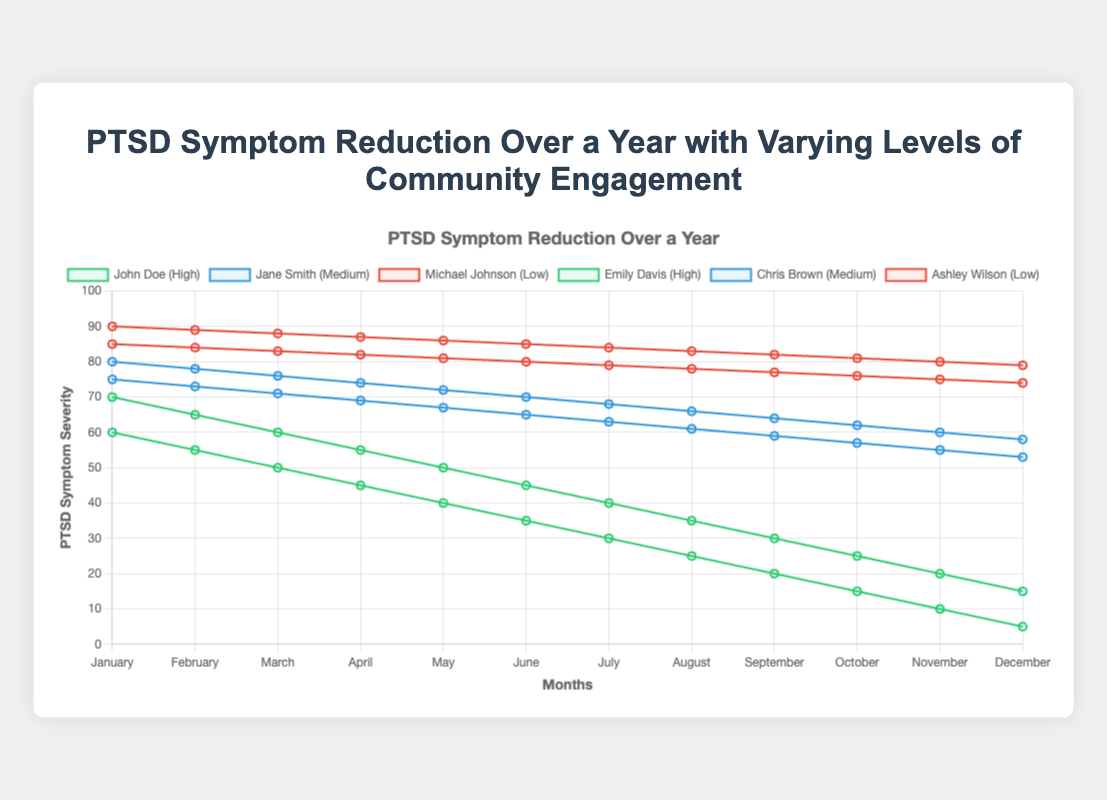What's the difference in PTSD symptoms between John Doe and Michael Johnson in January? John Doe's PTSD symptoms in January are 70, while Michael Johnson's are 90. The difference is 90 - 70 = 20.
Answer: 20 Comparing Emily Davis and Ashley Wilson's PTSD symptoms, who shows a greater reduction by December? Emily Davis starts with 60 symptoms and reduces to 5 by December, a reduction of 60 - 5 = 55. Ashley Wilson starts at 85 and reduces to 74, a reduction of 85 - 74 = 11. Emily Davis shows a greater reduction.
Answer: Emily Davis What is the average PTSD symptom severity for participants with high community engagement in July? John Doe has 40 symptoms, and Emily Davis has 30 symptoms in July. The average is (40 + 30) / 2 = 35.
Answer: 35 Which month sees the largest reduction in symptoms for Jane Smith? Jane Smith's symptoms drop from 80 to 78 in February (2 less), 78 to 76 in March (2 less), and so on. The largest monthly drop is consistently 2.
Answer: 2 (consistent each month) How do the PTSD symptoms in February compare between John Doe and Chris Brown? In February, John Doe has 65 PTSD symptoms, and Chris Brown has 73. Since 65 < 73, John Doe has fewer symptoms.
Answer: John Doe has fewer symptoms What is the median PTSD symptom severity for Michael Johnson over the year? Michael Johnson's symptoms are [90, 89, 88, 87, 86, 85, 84, 83, 82, 81, 80, 79]. The median is the average of the 6th (85) and 7th (84) values: (85 + 84) / 2 = 84.5.
Answer: 84.5 How does Ashley Wilson's PTSD symptom trend compare to the general trend for participants with low community engagement? Both Ashley Wilson and Michael Johnson show a gradual decrease in symptoms, indicating a slow reduction over the year.
Answer: Gradual decrease Who among the participants shows the steepest decline in PTSD symptoms over the year? Emily Davis starts at 60 and declines to 5, a total drop of 55 points. Other participants show smaller declines.
Answer: Emily Davis In which month do participants with medium community engagement levels show the same PTSD symptom count? In May, both Jane Smith and Chris Brown have different symptom counts (72 vs. 67, respectively). Upon checking all months, we find no matches.
Answer: None What's the combined PTSD symptom count for all participants in December? Adding PTSD symptoms in December: 15 (John Doe) + 58 (Jane Smith) + 79 (Michael Johnson) + 5 (Emily Davis) + 53 (Chris Brown) + 74 (Ashley Wilson) = 284.
Answer: 284 